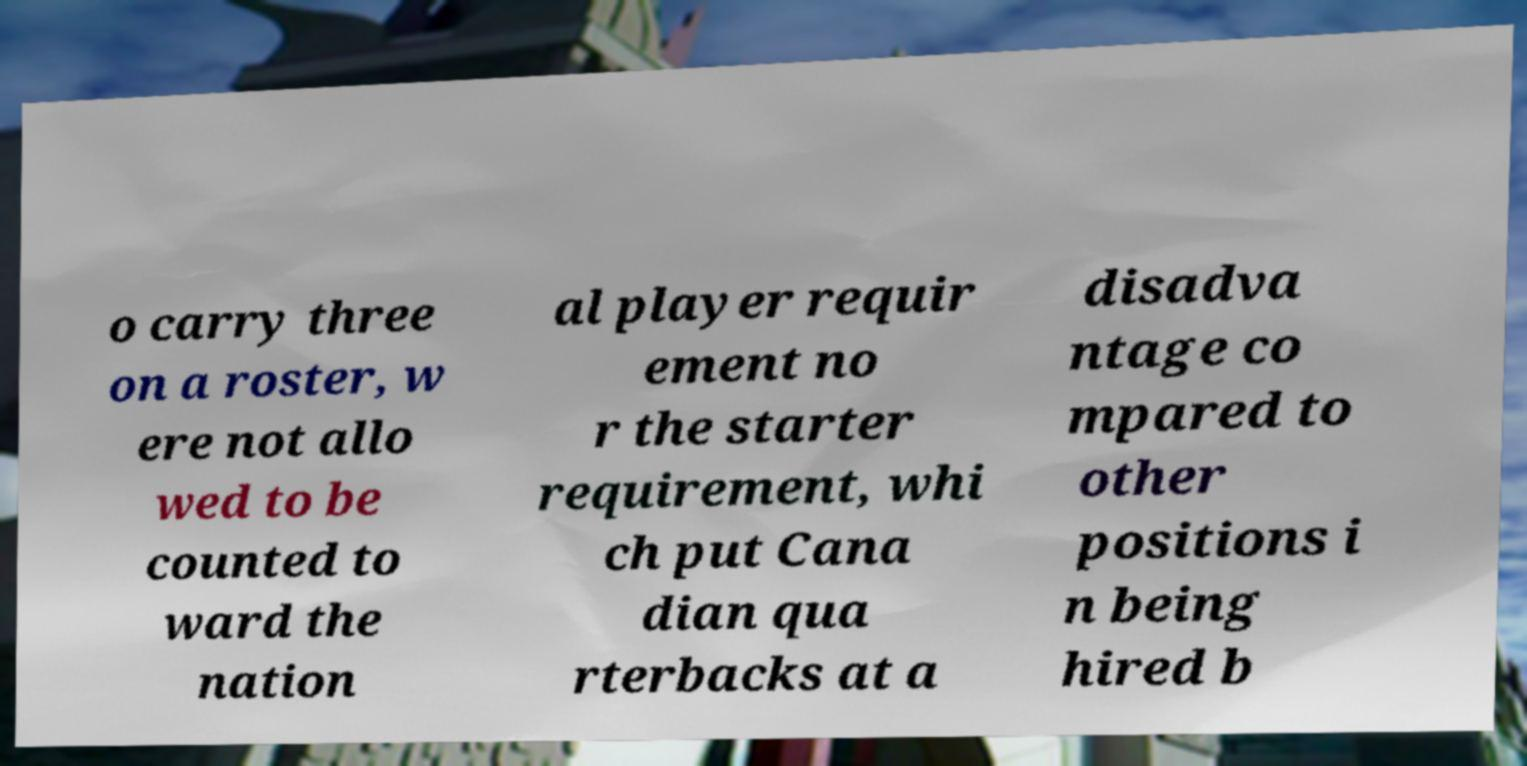Can you accurately transcribe the text from the provided image for me? o carry three on a roster, w ere not allo wed to be counted to ward the nation al player requir ement no r the starter requirement, whi ch put Cana dian qua rterbacks at a disadva ntage co mpared to other positions i n being hired b 